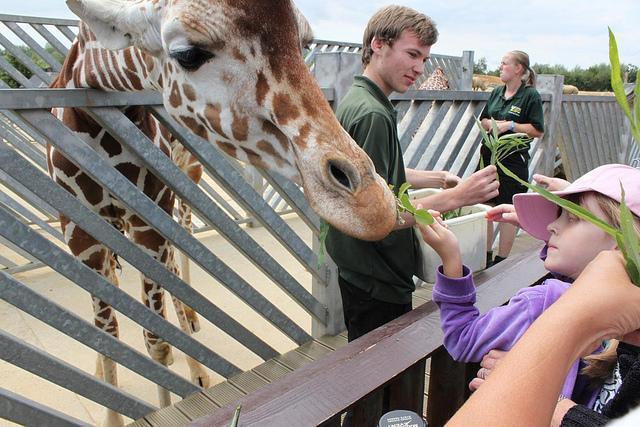How many people are visible?
Give a very brief answer. 4. 